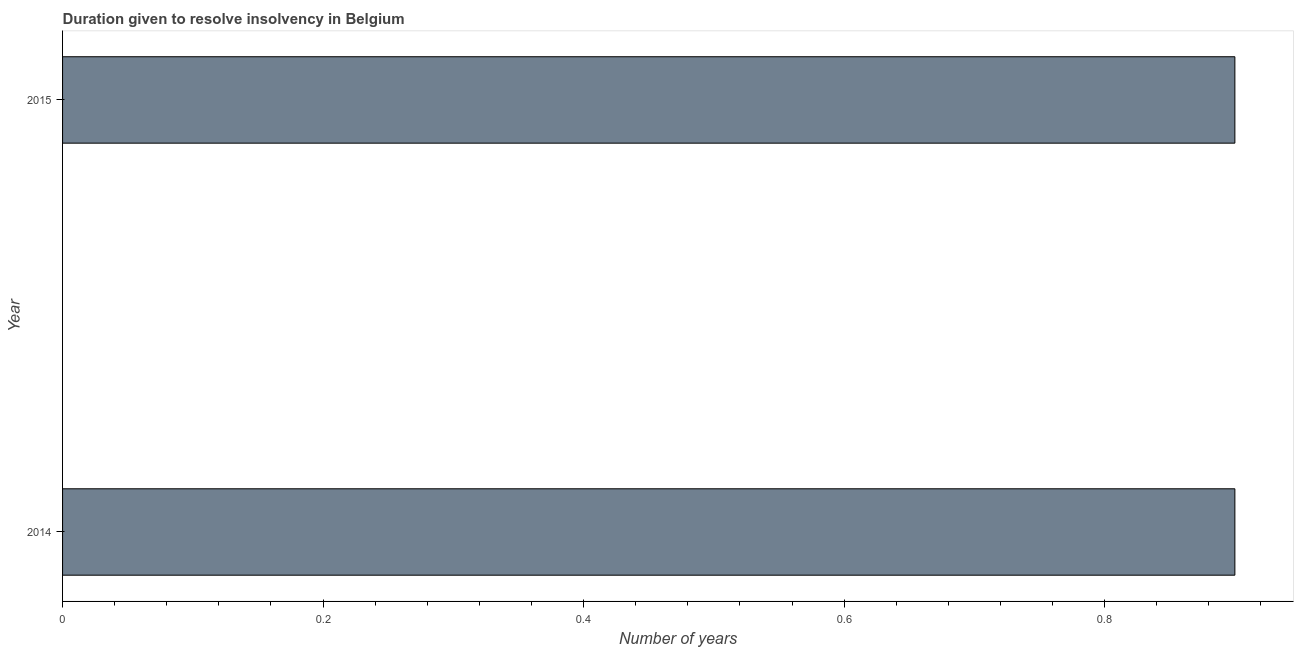Does the graph contain any zero values?
Ensure brevity in your answer.  No. Does the graph contain grids?
Offer a terse response. No. What is the title of the graph?
Your answer should be compact. Duration given to resolve insolvency in Belgium. What is the label or title of the X-axis?
Make the answer very short. Number of years. Across all years, what is the maximum number of years to resolve insolvency?
Your answer should be compact. 0.9. Across all years, what is the minimum number of years to resolve insolvency?
Give a very brief answer. 0.9. In which year was the number of years to resolve insolvency maximum?
Provide a short and direct response. 2014. In which year was the number of years to resolve insolvency minimum?
Provide a succinct answer. 2014. What is the sum of the number of years to resolve insolvency?
Your answer should be very brief. 1.8. What is the median number of years to resolve insolvency?
Offer a very short reply. 0.9. In how many years, is the number of years to resolve insolvency greater than 0.56 ?
Your answer should be very brief. 2. What is the ratio of the number of years to resolve insolvency in 2014 to that in 2015?
Your response must be concise. 1. How many bars are there?
Ensure brevity in your answer.  2. Are all the bars in the graph horizontal?
Make the answer very short. Yes. How many years are there in the graph?
Offer a very short reply. 2. What is the difference between two consecutive major ticks on the X-axis?
Give a very brief answer. 0.2. What is the ratio of the Number of years in 2014 to that in 2015?
Your answer should be very brief. 1. 